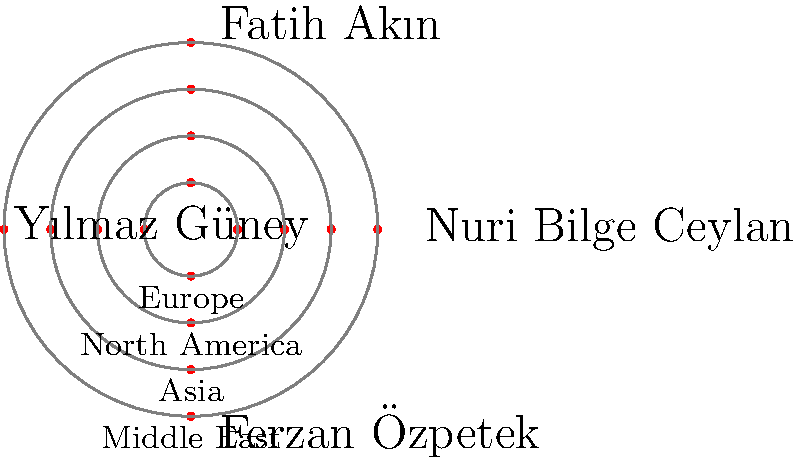In the polar network graph representing the influence of Turkish directors on world cinema, which director appears to have the most significant impact on European cinema? To determine which Turkish director has the most significant impact on European cinema, we need to analyze the polar network graph:

1. The graph shows four Turkish directors: Nuri Bilge Ceylan, Fatih Akın, Yılmaz Güney, and Ferzan Özpetek.
2. The concentric circles represent different regions: Europe, North America, Asia, and the Middle East (from outer to inner).
3. The distance of each point from the center indicates the level of influence in that region.
4. For European cinema (the outermost circle), we need to compare the positions of the points for each director.

Analyzing the graph:
1. Nuri Bilge Ceylan: The point is relatively far from the center on the European circle.
2. Fatih Akın: The point is slightly closer to the center compared to Ceylan's.
3. Yılmaz Güney: The point is the farthest from the center on the European circle.
4. Ferzan Özpetek: The point is the closest to the center among all directors for the European circle.

Based on this analysis, Yılmaz Güney's point is positioned farthest from the center on the European circle, indicating the most significant impact on European cinema among the four directors.
Answer: Yılmaz Güney 